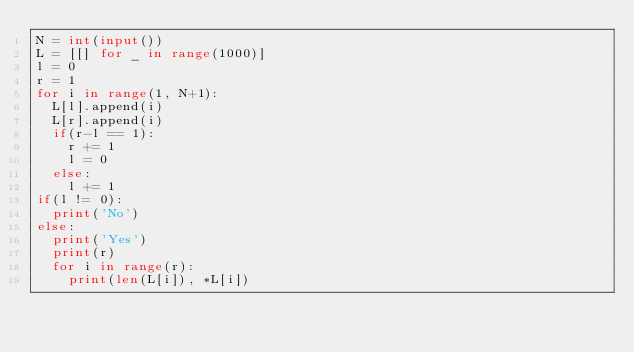Convert code to text. <code><loc_0><loc_0><loc_500><loc_500><_Python_>N = int(input())
L = [[] for _ in range(1000)]
l = 0
r = 1
for i in range(1, N+1):
  L[l].append(i)
  L[r].append(i)
  if(r-l == 1):
    r += 1
    l = 0
  else:
    l += 1
if(l != 0):
  print('No')
else:
  print('Yes')
  print(r)
  for i in range(r):
    print(len(L[i]), *L[i])</code> 